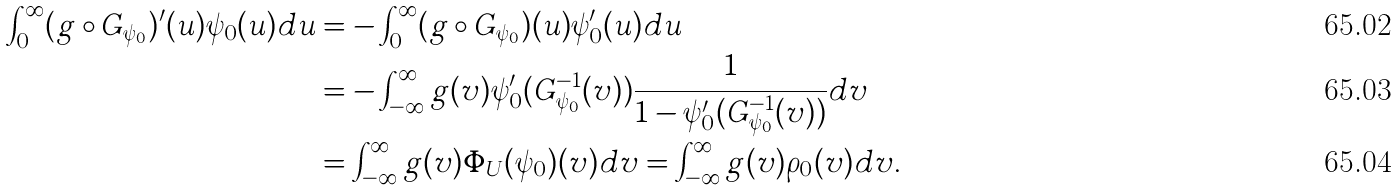<formula> <loc_0><loc_0><loc_500><loc_500>\int ^ { \infty } _ { 0 } ( g \circ G _ { \psi _ { 0 } } ) ^ { \prime } ( u ) \psi _ { 0 } ( u ) d u & = - \int ^ { \infty } _ { 0 } ( g \circ G _ { \psi _ { 0 } } ) ( u ) \psi _ { 0 } ^ { \prime } ( u ) d u \\ & = - \int ^ { \infty } _ { - \infty } g ( v ) \psi _ { 0 } ^ { \prime } ( G _ { \psi _ { 0 } } ^ { - 1 } ( v ) ) \frac { 1 } { 1 - \psi _ { 0 } ^ { \prime } ( G _ { \psi _ { 0 } } ^ { - 1 } ( v ) ) } d v \\ & = \int ^ { \infty } _ { - \infty } g ( v ) \Phi _ { U } ( \psi _ { 0 } ) ( v ) d v = \int ^ { \infty } _ { - \infty } g ( v ) \rho _ { 0 } ( v ) d v .</formula> 